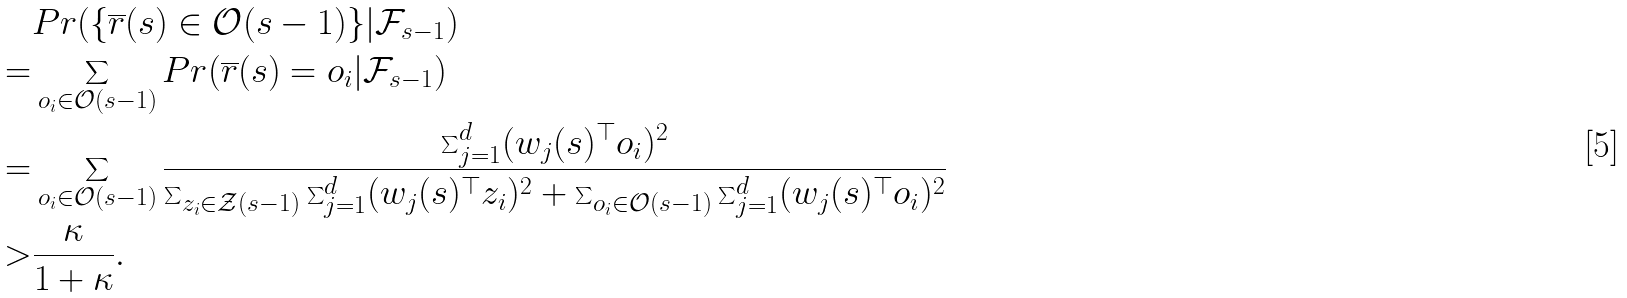<formula> <loc_0><loc_0><loc_500><loc_500>& P r ( \{ \overline { r } ( s ) \in \mathcal { O } ( s - 1 ) \} | \mathcal { F } _ { s - 1 } ) \\ = & \sum _ { o _ { i } \in \mathcal { O } ( s - 1 ) } P r ( \overline { r } ( s ) = o _ { i } | \mathcal { F } _ { s - 1 } ) \\ = & \sum _ { o _ { i } \in \mathcal { O } ( s - 1 ) } \frac { \sum _ { j = 1 } ^ { d } ( w _ { j } ( s ) ^ { \top } o _ { i } ) ^ { 2 } } { \sum _ { z _ { i } \in \mathcal { Z } ( s - 1 ) } \sum _ { j = 1 } ^ { d } ( w _ { j } ( s ) ^ { \top } z _ { i } ) ^ { 2 } + \sum _ { o _ { i } \in \mathcal { O } ( s - 1 ) } \sum _ { j = 1 } ^ { d } ( w _ { j } ( s ) ^ { \top } o _ { i } ) ^ { 2 } } \\ > & \frac { \kappa } { 1 + \kappa } .</formula> 